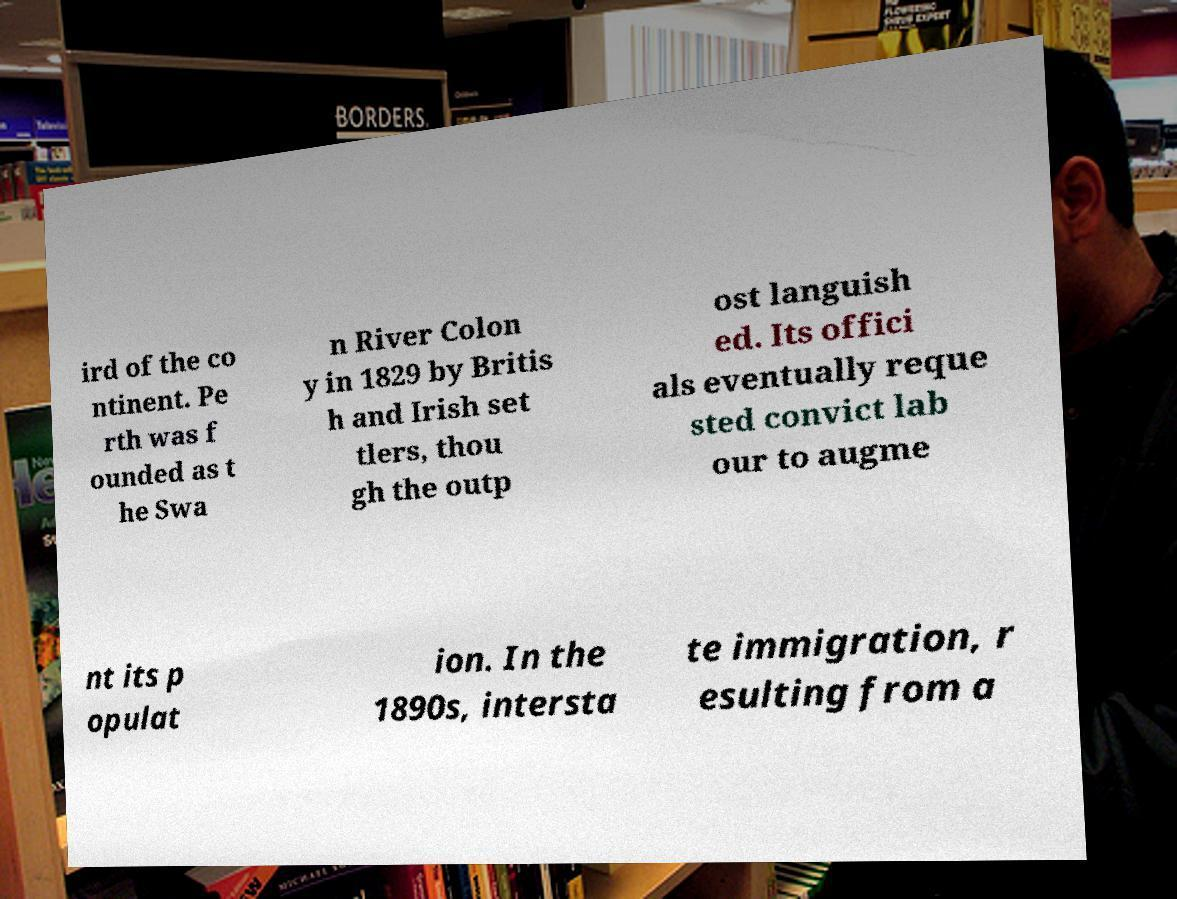I need the written content from this picture converted into text. Can you do that? ird of the co ntinent. Pe rth was f ounded as t he Swa n River Colon y in 1829 by Britis h and Irish set tlers, thou gh the outp ost languish ed. Its offici als eventually reque sted convict lab our to augme nt its p opulat ion. In the 1890s, intersta te immigration, r esulting from a 